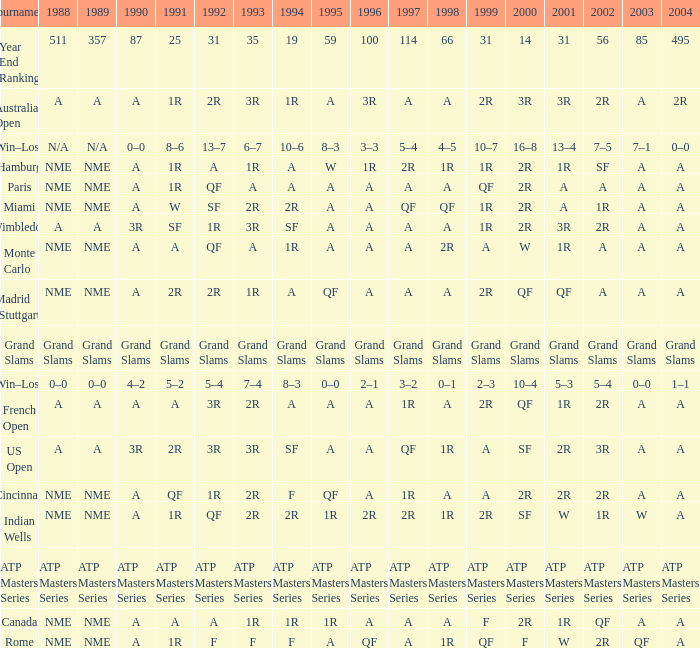What shows for 1988 when 1994 shows 10–6? N/A. 